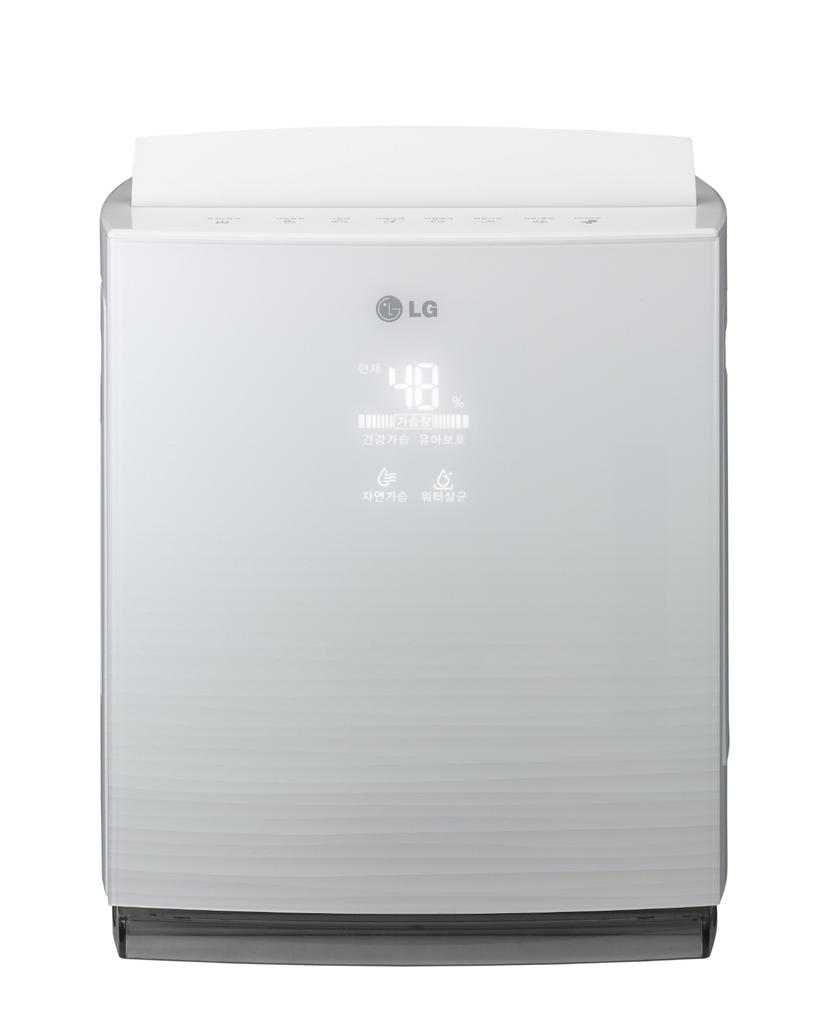Provide a one-sentence caption for the provided image. the LG device says 48 degrees on the front of it. 